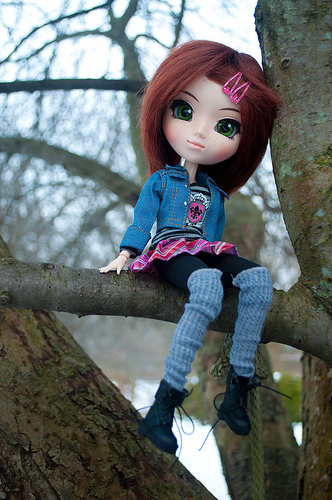<image>
Can you confirm if the doll is on the branch? Yes. Looking at the image, I can see the doll is positioned on top of the branch, with the branch providing support. Where is the doll in relation to the branch? Is it on the branch? Yes. Looking at the image, I can see the doll is positioned on top of the branch, with the branch providing support. 